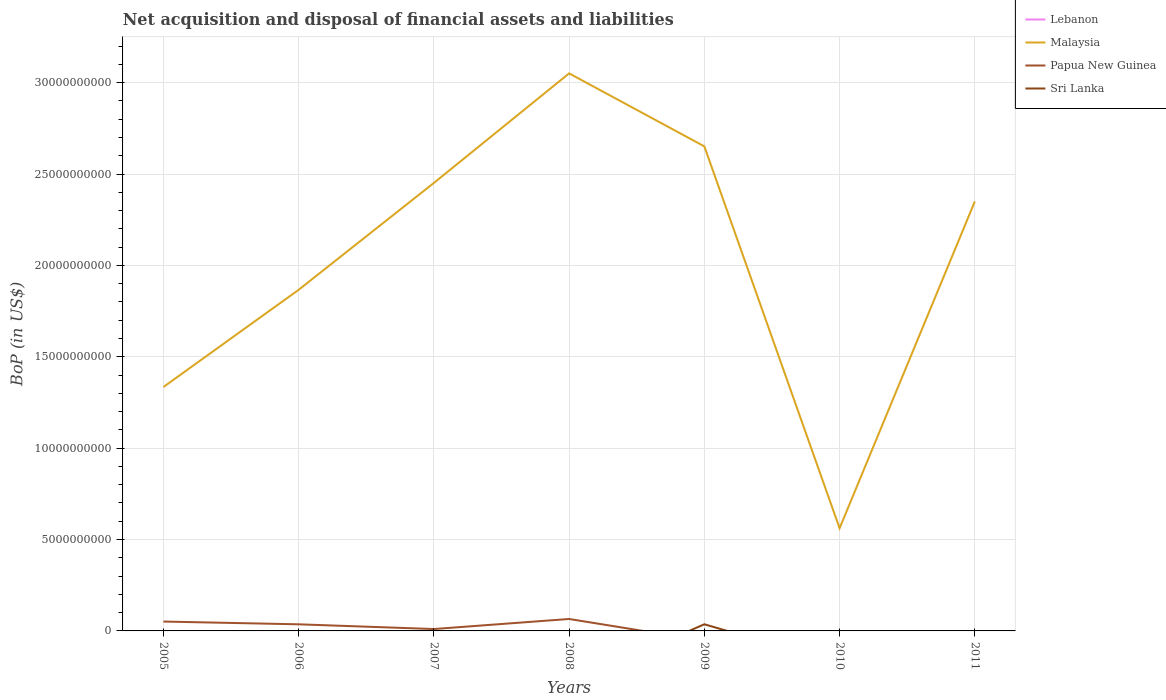How many different coloured lines are there?
Make the answer very short. 3. Does the line corresponding to Malaysia intersect with the line corresponding to Lebanon?
Your answer should be compact. No. What is the total Balance of Payments in Malaysia in the graph?
Make the answer very short. -1.18e+1. What is the difference between the highest and the second highest Balance of Payments in Papua New Guinea?
Make the answer very short. 6.54e+08. Is the Balance of Payments in Lebanon strictly greater than the Balance of Payments in Sri Lanka over the years?
Make the answer very short. No. How many lines are there?
Your answer should be very brief. 3. How many years are there in the graph?
Ensure brevity in your answer.  7. What is the difference between two consecutive major ticks on the Y-axis?
Give a very brief answer. 5.00e+09. Does the graph contain any zero values?
Offer a terse response. Yes. How are the legend labels stacked?
Your answer should be very brief. Vertical. What is the title of the graph?
Your answer should be very brief. Net acquisition and disposal of financial assets and liabilities. Does "Cyprus" appear as one of the legend labels in the graph?
Your response must be concise. No. What is the label or title of the Y-axis?
Give a very brief answer. BoP (in US$). What is the BoP (in US$) of Malaysia in 2005?
Make the answer very short. 1.33e+1. What is the BoP (in US$) of Papua New Guinea in 2005?
Keep it short and to the point. 5.13e+08. What is the BoP (in US$) of Sri Lanka in 2005?
Give a very brief answer. 0. What is the BoP (in US$) of Lebanon in 2006?
Keep it short and to the point. 0. What is the BoP (in US$) in Malaysia in 2006?
Make the answer very short. 1.87e+1. What is the BoP (in US$) of Papua New Guinea in 2006?
Make the answer very short. 3.62e+08. What is the BoP (in US$) in Sri Lanka in 2006?
Your answer should be very brief. 0. What is the BoP (in US$) in Malaysia in 2007?
Provide a short and direct response. 2.45e+1. What is the BoP (in US$) of Papua New Guinea in 2007?
Offer a very short reply. 1.04e+08. What is the BoP (in US$) in Sri Lanka in 2007?
Keep it short and to the point. 0. What is the BoP (in US$) in Malaysia in 2008?
Ensure brevity in your answer.  3.05e+1. What is the BoP (in US$) in Papua New Guinea in 2008?
Your answer should be very brief. 6.54e+08. What is the BoP (in US$) in Lebanon in 2009?
Your answer should be compact. 0. What is the BoP (in US$) in Malaysia in 2009?
Your answer should be very brief. 2.65e+1. What is the BoP (in US$) of Sri Lanka in 2009?
Provide a succinct answer. 3.64e+08. What is the BoP (in US$) in Lebanon in 2010?
Ensure brevity in your answer.  0. What is the BoP (in US$) in Malaysia in 2010?
Offer a terse response. 5.62e+09. What is the BoP (in US$) of Papua New Guinea in 2010?
Offer a very short reply. 0. What is the BoP (in US$) in Sri Lanka in 2010?
Your answer should be very brief. 0. What is the BoP (in US$) of Lebanon in 2011?
Provide a short and direct response. 0. What is the BoP (in US$) in Malaysia in 2011?
Make the answer very short. 2.35e+1. What is the BoP (in US$) of Papua New Guinea in 2011?
Make the answer very short. 0. Across all years, what is the maximum BoP (in US$) in Malaysia?
Your response must be concise. 3.05e+1. Across all years, what is the maximum BoP (in US$) of Papua New Guinea?
Your answer should be compact. 6.54e+08. Across all years, what is the maximum BoP (in US$) of Sri Lanka?
Your answer should be compact. 3.64e+08. Across all years, what is the minimum BoP (in US$) in Malaysia?
Your response must be concise. 5.62e+09. Across all years, what is the minimum BoP (in US$) of Sri Lanka?
Give a very brief answer. 0. What is the total BoP (in US$) in Lebanon in the graph?
Your answer should be very brief. 0. What is the total BoP (in US$) of Malaysia in the graph?
Offer a terse response. 1.43e+11. What is the total BoP (in US$) of Papua New Guinea in the graph?
Offer a terse response. 1.63e+09. What is the total BoP (in US$) of Sri Lanka in the graph?
Your response must be concise. 3.64e+08. What is the difference between the BoP (in US$) in Malaysia in 2005 and that in 2006?
Keep it short and to the point. -5.32e+09. What is the difference between the BoP (in US$) of Papua New Guinea in 2005 and that in 2006?
Your answer should be very brief. 1.51e+08. What is the difference between the BoP (in US$) in Malaysia in 2005 and that in 2007?
Provide a short and direct response. -1.12e+1. What is the difference between the BoP (in US$) in Papua New Guinea in 2005 and that in 2007?
Your answer should be very brief. 4.10e+08. What is the difference between the BoP (in US$) in Malaysia in 2005 and that in 2008?
Make the answer very short. -1.72e+1. What is the difference between the BoP (in US$) of Papua New Guinea in 2005 and that in 2008?
Make the answer very short. -1.40e+08. What is the difference between the BoP (in US$) of Malaysia in 2005 and that in 2009?
Your answer should be very brief. -1.32e+1. What is the difference between the BoP (in US$) in Malaysia in 2005 and that in 2010?
Provide a short and direct response. 7.73e+09. What is the difference between the BoP (in US$) in Malaysia in 2005 and that in 2011?
Offer a very short reply. -1.02e+1. What is the difference between the BoP (in US$) in Malaysia in 2006 and that in 2007?
Keep it short and to the point. -5.85e+09. What is the difference between the BoP (in US$) in Papua New Guinea in 2006 and that in 2007?
Provide a succinct answer. 2.58e+08. What is the difference between the BoP (in US$) in Malaysia in 2006 and that in 2008?
Give a very brief answer. -1.18e+1. What is the difference between the BoP (in US$) in Papua New Guinea in 2006 and that in 2008?
Provide a short and direct response. -2.92e+08. What is the difference between the BoP (in US$) of Malaysia in 2006 and that in 2009?
Offer a terse response. -7.85e+09. What is the difference between the BoP (in US$) in Malaysia in 2006 and that in 2010?
Your answer should be very brief. 1.30e+1. What is the difference between the BoP (in US$) of Malaysia in 2006 and that in 2011?
Keep it short and to the point. -4.83e+09. What is the difference between the BoP (in US$) in Malaysia in 2007 and that in 2008?
Your answer should be compact. -5.99e+09. What is the difference between the BoP (in US$) of Papua New Guinea in 2007 and that in 2008?
Your response must be concise. -5.50e+08. What is the difference between the BoP (in US$) of Malaysia in 2007 and that in 2009?
Ensure brevity in your answer.  -2.00e+09. What is the difference between the BoP (in US$) of Malaysia in 2007 and that in 2010?
Offer a terse response. 1.89e+1. What is the difference between the BoP (in US$) in Malaysia in 2007 and that in 2011?
Your answer should be very brief. 1.02e+09. What is the difference between the BoP (in US$) in Malaysia in 2008 and that in 2009?
Ensure brevity in your answer.  3.99e+09. What is the difference between the BoP (in US$) of Malaysia in 2008 and that in 2010?
Ensure brevity in your answer.  2.49e+1. What is the difference between the BoP (in US$) of Malaysia in 2008 and that in 2011?
Provide a short and direct response. 7.01e+09. What is the difference between the BoP (in US$) of Malaysia in 2009 and that in 2010?
Your answer should be very brief. 2.09e+1. What is the difference between the BoP (in US$) of Malaysia in 2009 and that in 2011?
Provide a succinct answer. 3.02e+09. What is the difference between the BoP (in US$) in Malaysia in 2010 and that in 2011?
Ensure brevity in your answer.  -1.79e+1. What is the difference between the BoP (in US$) in Malaysia in 2005 and the BoP (in US$) in Papua New Guinea in 2006?
Ensure brevity in your answer.  1.30e+1. What is the difference between the BoP (in US$) of Malaysia in 2005 and the BoP (in US$) of Papua New Guinea in 2007?
Your response must be concise. 1.32e+1. What is the difference between the BoP (in US$) in Malaysia in 2005 and the BoP (in US$) in Papua New Guinea in 2008?
Your answer should be compact. 1.27e+1. What is the difference between the BoP (in US$) of Malaysia in 2005 and the BoP (in US$) of Sri Lanka in 2009?
Provide a short and direct response. 1.30e+1. What is the difference between the BoP (in US$) in Papua New Guinea in 2005 and the BoP (in US$) in Sri Lanka in 2009?
Give a very brief answer. 1.49e+08. What is the difference between the BoP (in US$) in Malaysia in 2006 and the BoP (in US$) in Papua New Guinea in 2007?
Your answer should be very brief. 1.86e+1. What is the difference between the BoP (in US$) in Malaysia in 2006 and the BoP (in US$) in Papua New Guinea in 2008?
Make the answer very short. 1.80e+1. What is the difference between the BoP (in US$) in Malaysia in 2006 and the BoP (in US$) in Sri Lanka in 2009?
Your answer should be compact. 1.83e+1. What is the difference between the BoP (in US$) of Papua New Guinea in 2006 and the BoP (in US$) of Sri Lanka in 2009?
Offer a very short reply. -2.24e+06. What is the difference between the BoP (in US$) of Malaysia in 2007 and the BoP (in US$) of Papua New Guinea in 2008?
Your answer should be compact. 2.39e+1. What is the difference between the BoP (in US$) of Malaysia in 2007 and the BoP (in US$) of Sri Lanka in 2009?
Your answer should be compact. 2.42e+1. What is the difference between the BoP (in US$) of Papua New Guinea in 2007 and the BoP (in US$) of Sri Lanka in 2009?
Keep it short and to the point. -2.60e+08. What is the difference between the BoP (in US$) of Malaysia in 2008 and the BoP (in US$) of Sri Lanka in 2009?
Your answer should be very brief. 3.01e+1. What is the difference between the BoP (in US$) in Papua New Guinea in 2008 and the BoP (in US$) in Sri Lanka in 2009?
Provide a short and direct response. 2.90e+08. What is the average BoP (in US$) in Lebanon per year?
Give a very brief answer. 0. What is the average BoP (in US$) in Malaysia per year?
Your answer should be very brief. 2.04e+1. What is the average BoP (in US$) of Papua New Guinea per year?
Ensure brevity in your answer.  2.33e+08. What is the average BoP (in US$) in Sri Lanka per year?
Provide a short and direct response. 5.20e+07. In the year 2005, what is the difference between the BoP (in US$) of Malaysia and BoP (in US$) of Papua New Guinea?
Make the answer very short. 1.28e+1. In the year 2006, what is the difference between the BoP (in US$) of Malaysia and BoP (in US$) of Papua New Guinea?
Offer a very short reply. 1.83e+1. In the year 2007, what is the difference between the BoP (in US$) in Malaysia and BoP (in US$) in Papua New Guinea?
Provide a succinct answer. 2.44e+1. In the year 2008, what is the difference between the BoP (in US$) of Malaysia and BoP (in US$) of Papua New Guinea?
Ensure brevity in your answer.  2.99e+1. In the year 2009, what is the difference between the BoP (in US$) in Malaysia and BoP (in US$) in Sri Lanka?
Your answer should be compact. 2.62e+1. What is the ratio of the BoP (in US$) of Malaysia in 2005 to that in 2006?
Your answer should be very brief. 0.71. What is the ratio of the BoP (in US$) of Papua New Guinea in 2005 to that in 2006?
Provide a succinct answer. 1.42. What is the ratio of the BoP (in US$) in Malaysia in 2005 to that in 2007?
Your answer should be very brief. 0.54. What is the ratio of the BoP (in US$) in Papua New Guinea in 2005 to that in 2007?
Provide a short and direct response. 4.95. What is the ratio of the BoP (in US$) of Malaysia in 2005 to that in 2008?
Give a very brief answer. 0.44. What is the ratio of the BoP (in US$) of Papua New Guinea in 2005 to that in 2008?
Provide a short and direct response. 0.79. What is the ratio of the BoP (in US$) in Malaysia in 2005 to that in 2009?
Your response must be concise. 0.5. What is the ratio of the BoP (in US$) of Malaysia in 2005 to that in 2010?
Make the answer very short. 2.38. What is the ratio of the BoP (in US$) of Malaysia in 2005 to that in 2011?
Give a very brief answer. 0.57. What is the ratio of the BoP (in US$) of Malaysia in 2006 to that in 2007?
Offer a very short reply. 0.76. What is the ratio of the BoP (in US$) in Papua New Guinea in 2006 to that in 2007?
Offer a very short reply. 3.49. What is the ratio of the BoP (in US$) of Malaysia in 2006 to that in 2008?
Make the answer very short. 0.61. What is the ratio of the BoP (in US$) in Papua New Guinea in 2006 to that in 2008?
Keep it short and to the point. 0.55. What is the ratio of the BoP (in US$) in Malaysia in 2006 to that in 2009?
Ensure brevity in your answer.  0.7. What is the ratio of the BoP (in US$) in Malaysia in 2006 to that in 2010?
Your answer should be very brief. 3.32. What is the ratio of the BoP (in US$) of Malaysia in 2006 to that in 2011?
Keep it short and to the point. 0.79. What is the ratio of the BoP (in US$) of Malaysia in 2007 to that in 2008?
Make the answer very short. 0.8. What is the ratio of the BoP (in US$) in Papua New Guinea in 2007 to that in 2008?
Provide a succinct answer. 0.16. What is the ratio of the BoP (in US$) of Malaysia in 2007 to that in 2009?
Make the answer very short. 0.92. What is the ratio of the BoP (in US$) in Malaysia in 2007 to that in 2010?
Your answer should be compact. 4.36. What is the ratio of the BoP (in US$) of Malaysia in 2007 to that in 2011?
Provide a short and direct response. 1.04. What is the ratio of the BoP (in US$) of Malaysia in 2008 to that in 2009?
Offer a very short reply. 1.15. What is the ratio of the BoP (in US$) in Malaysia in 2008 to that in 2010?
Your answer should be very brief. 5.43. What is the ratio of the BoP (in US$) of Malaysia in 2008 to that in 2011?
Offer a very short reply. 1.3. What is the ratio of the BoP (in US$) in Malaysia in 2009 to that in 2010?
Your response must be concise. 4.72. What is the ratio of the BoP (in US$) in Malaysia in 2009 to that in 2011?
Provide a short and direct response. 1.13. What is the ratio of the BoP (in US$) in Malaysia in 2010 to that in 2011?
Offer a terse response. 0.24. What is the difference between the highest and the second highest BoP (in US$) in Malaysia?
Provide a succinct answer. 3.99e+09. What is the difference between the highest and the second highest BoP (in US$) of Papua New Guinea?
Your answer should be compact. 1.40e+08. What is the difference between the highest and the lowest BoP (in US$) of Malaysia?
Offer a very short reply. 2.49e+1. What is the difference between the highest and the lowest BoP (in US$) in Papua New Guinea?
Offer a terse response. 6.54e+08. What is the difference between the highest and the lowest BoP (in US$) of Sri Lanka?
Keep it short and to the point. 3.64e+08. 